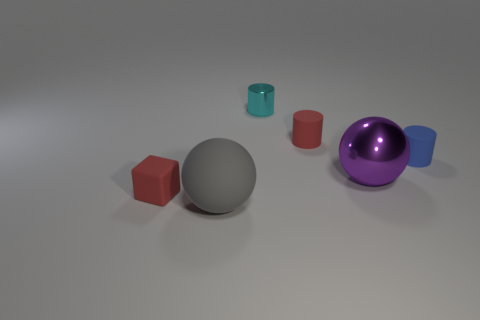There is a big ball that is behind the tiny red matte cube that is in front of the rubber cylinder behind the tiny blue cylinder; what is its material?
Ensure brevity in your answer.  Metal. Is there a big object of the same color as the shiny cylinder?
Offer a very short reply. No. Is the number of gray things that are behind the large metal ball less than the number of big purple shiny balls?
Offer a very short reply. Yes. Do the ball to the right of the metal cylinder and the red block have the same size?
Your answer should be compact. No. How many tiny rubber things are both on the left side of the blue cylinder and on the right side of the matte ball?
Your answer should be very brief. 1. What size is the red thing on the left side of the big ball in front of the red matte block?
Offer a very short reply. Small. Are there fewer tiny red cubes that are left of the small red cylinder than red rubber cylinders that are in front of the metal ball?
Your answer should be very brief. No. There is a large thing that is to the left of the shiny ball; does it have the same color as the small metal cylinder right of the rubber sphere?
Offer a very short reply. No. There is a tiny thing that is both in front of the tiny cyan cylinder and behind the small blue matte cylinder; what is its material?
Give a very brief answer. Rubber. Is there a tiny shiny object?
Keep it short and to the point. Yes. 